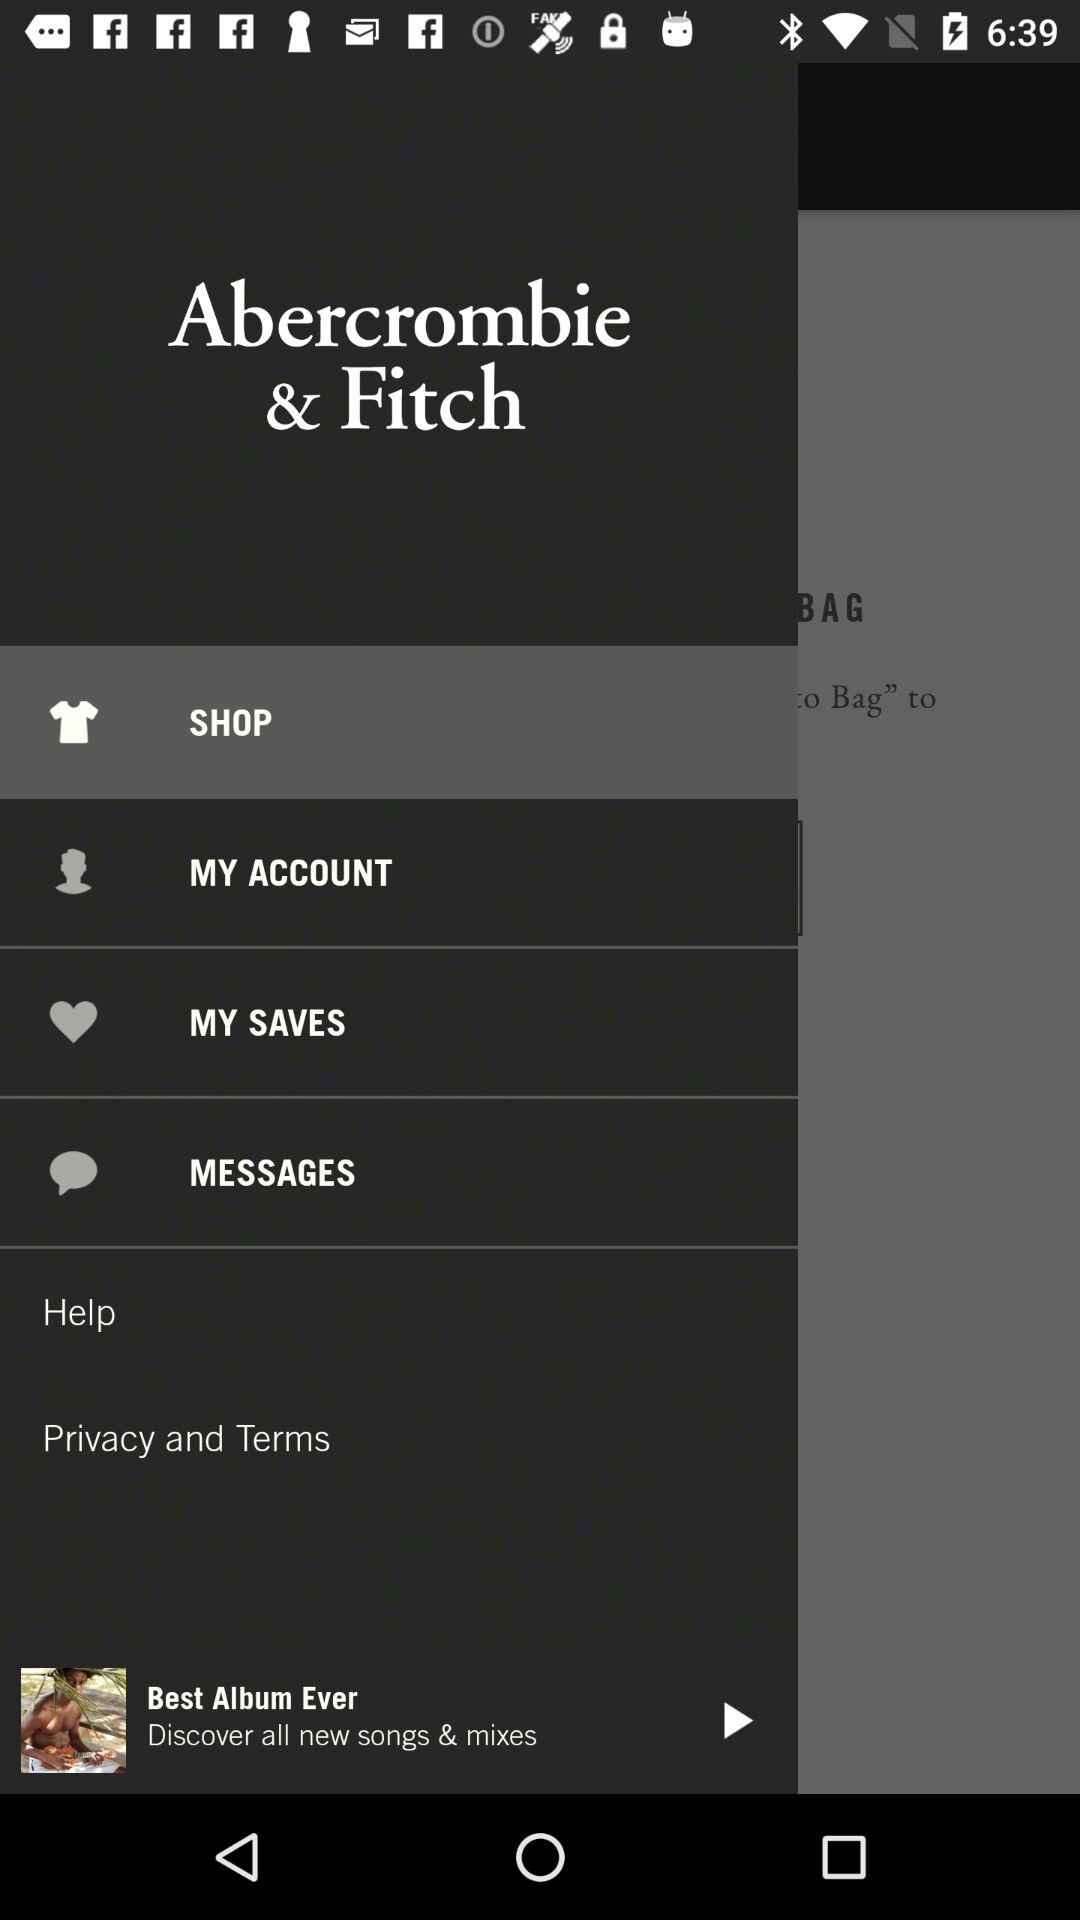What is the name of the application? The name of the application is "Abercrombie & Fitch". 